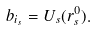<formula> <loc_0><loc_0><loc_500><loc_500>b _ { i _ { s } } = U _ { s } ( r _ { s } ^ { 0 } ) .</formula> 